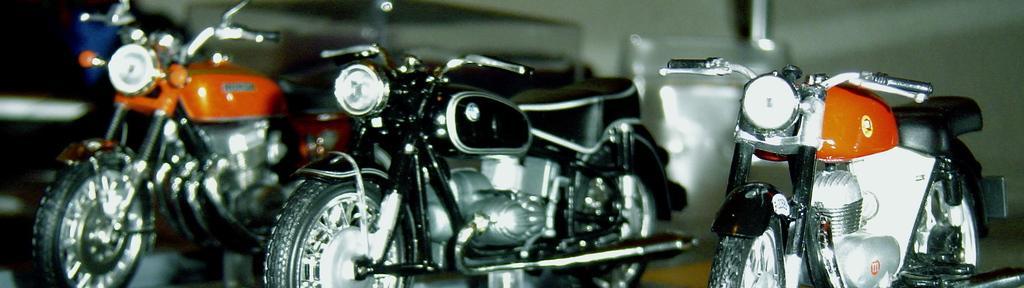Please provide a concise description of this image. This image consists of bikes in different colors. On the left and right, the bikes are in orange color. In the middle, the bike is in black color. At the bottom, there is a floor. 